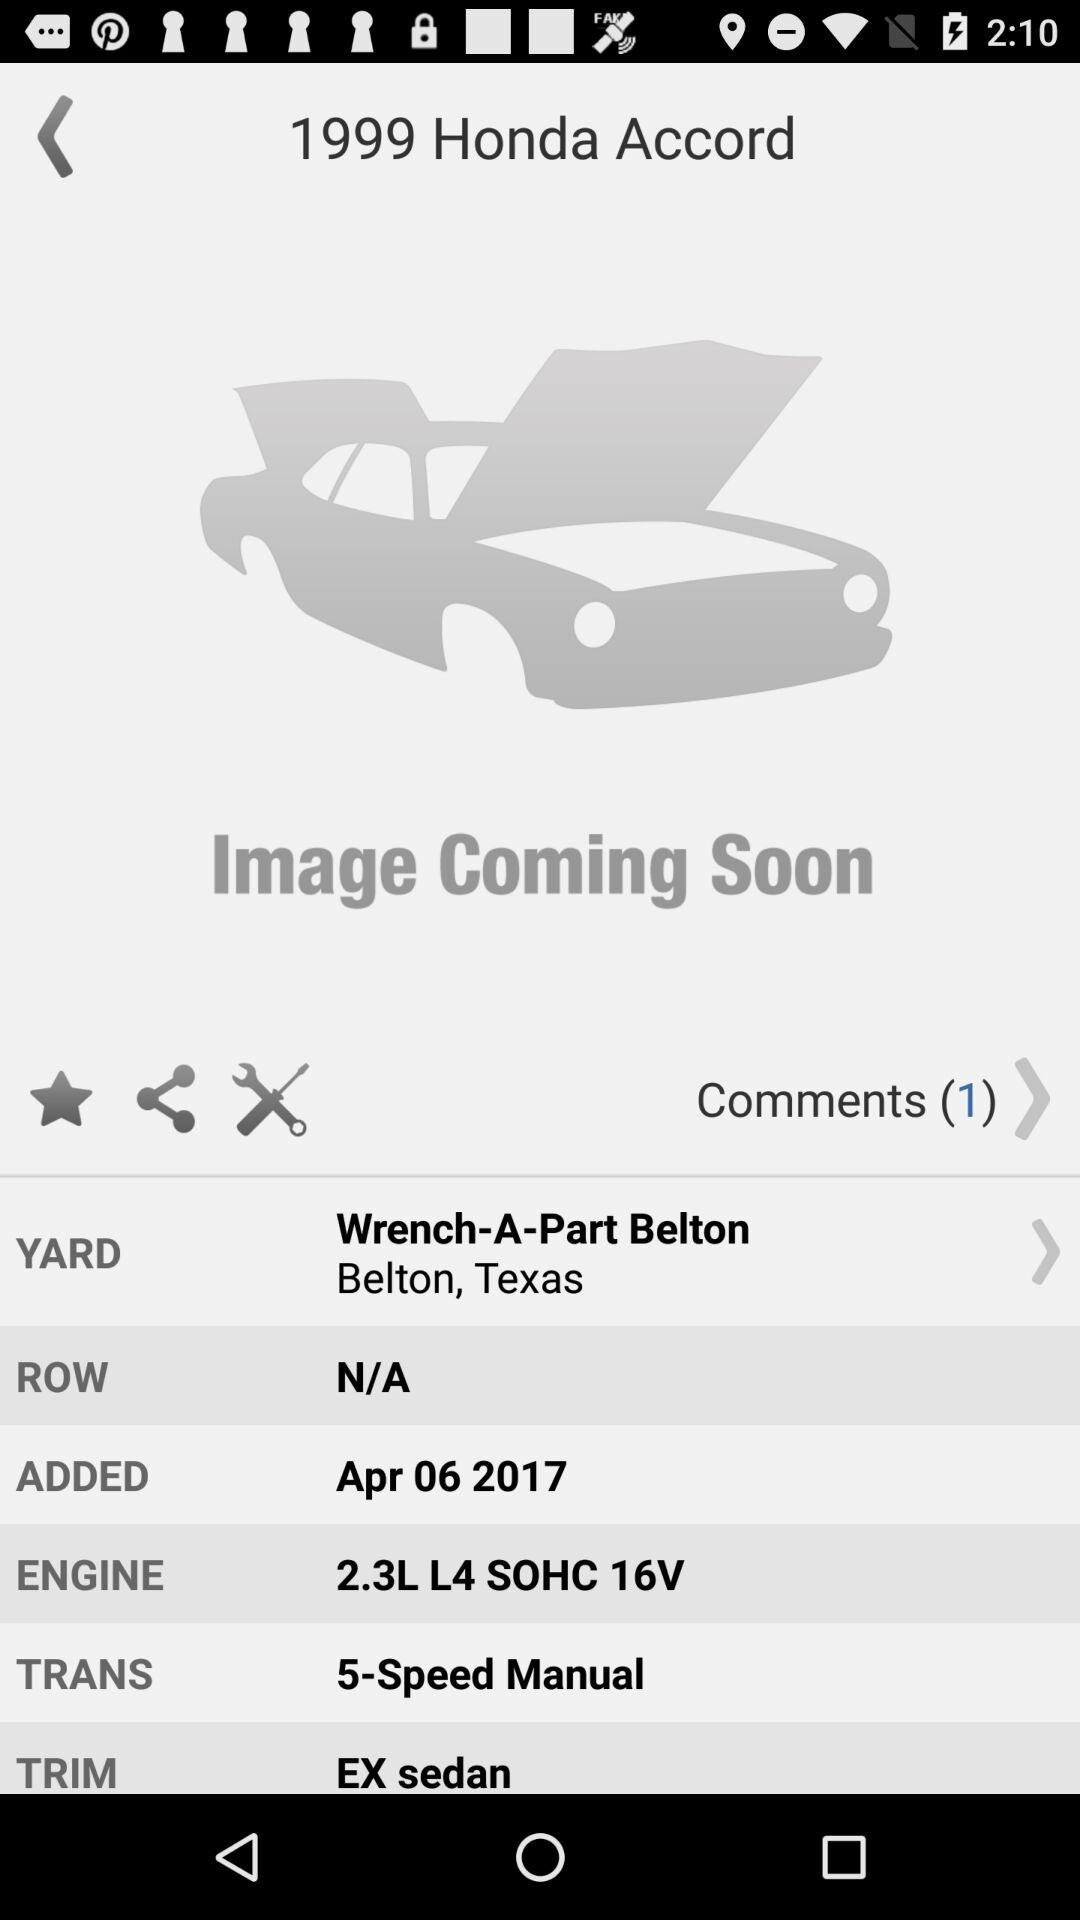What is the added date of the 1999 Honda Accord? The date is April 6, 2017. 